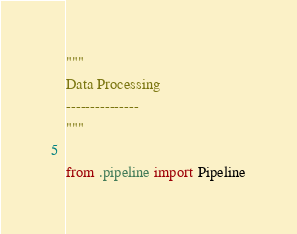Convert code to text. <code><loc_0><loc_0><loc_500><loc_500><_Python_>"""
Data Processing
---------------
"""

from .pipeline import Pipeline
</code> 